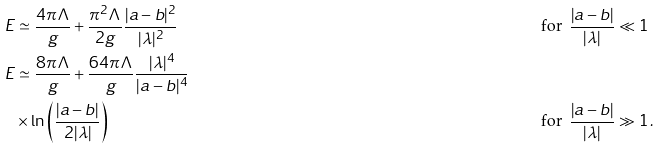Convert formula to latex. <formula><loc_0><loc_0><loc_500><loc_500>E & \simeq \frac { 4 \pi \Lambda } { g } + \frac { \pi ^ { 2 } \Lambda } { 2 g } \frac { | a - b | ^ { 2 } } { | \lambda | ^ { 2 } } & \, \text { for } \, \frac { | a - b | } { | \lambda | } \ll 1 & \\ E & \simeq \frac { 8 \pi \Lambda } { g } + \frac { 6 4 \pi \Lambda } { g } \frac { | \lambda | ^ { 4 } } { | a - b | ^ { 4 } } \\ & \times \ln \left ( \frac { | a - b | } { 2 | \lambda | } \right ) & \, \text { for } \, \frac { | a - b | } { | \lambda | } \gg 1 & \, .</formula> 